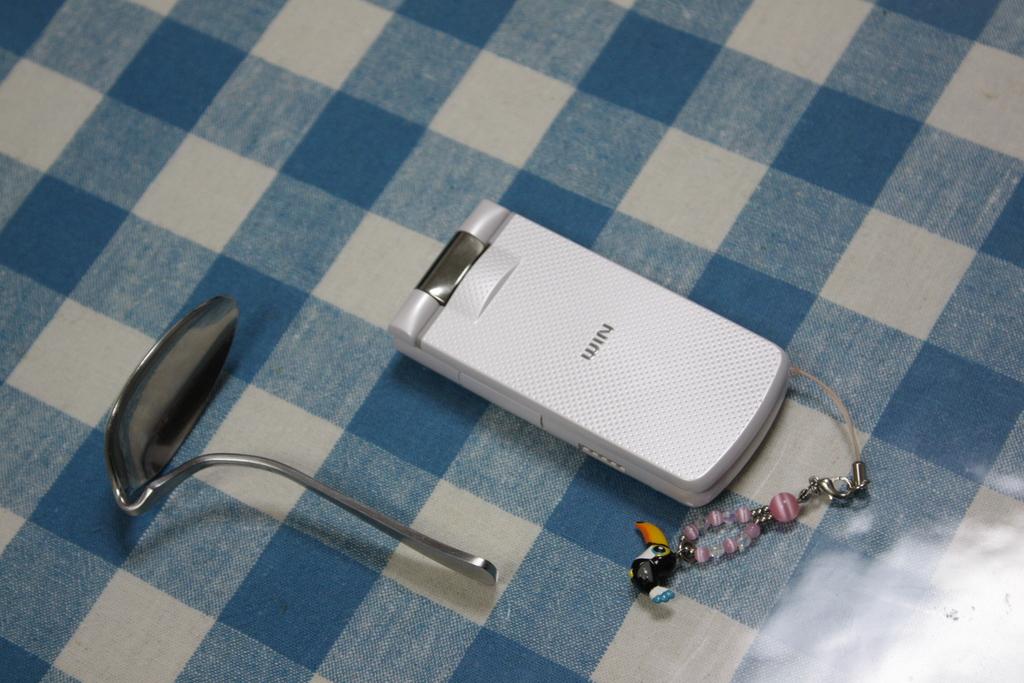What does the phone say on the top?
Provide a short and direct response. Win. What brand of phone is that?
Your answer should be compact. Win. 